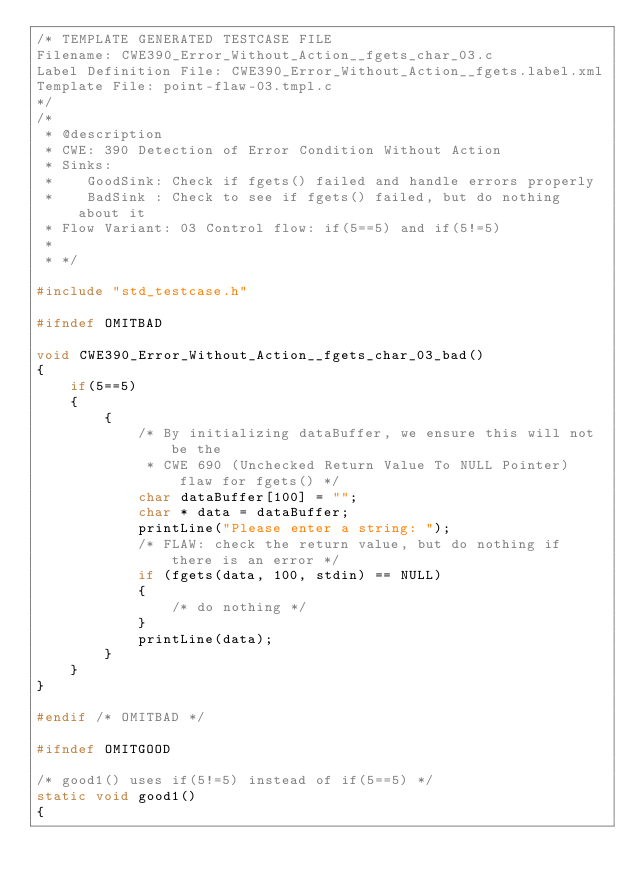Convert code to text. <code><loc_0><loc_0><loc_500><loc_500><_C_>/* TEMPLATE GENERATED TESTCASE FILE
Filename: CWE390_Error_Without_Action__fgets_char_03.c
Label Definition File: CWE390_Error_Without_Action__fgets.label.xml
Template File: point-flaw-03.tmpl.c
*/
/*
 * @description
 * CWE: 390 Detection of Error Condition Without Action
 * Sinks:
 *    GoodSink: Check if fgets() failed and handle errors properly
 *    BadSink : Check to see if fgets() failed, but do nothing about it
 * Flow Variant: 03 Control flow: if(5==5) and if(5!=5)
 *
 * */

#include "std_testcase.h"

#ifndef OMITBAD

void CWE390_Error_Without_Action__fgets_char_03_bad()
{
    if(5==5)
    {
        {
            /* By initializing dataBuffer, we ensure this will not be the
             * CWE 690 (Unchecked Return Value To NULL Pointer) flaw for fgets() */
            char dataBuffer[100] = "";
            char * data = dataBuffer;
            printLine("Please enter a string: ");
            /* FLAW: check the return value, but do nothing if there is an error */
            if (fgets(data, 100, stdin) == NULL)
            {
                /* do nothing */
            }
            printLine(data);
        }
    }
}

#endif /* OMITBAD */

#ifndef OMITGOOD

/* good1() uses if(5!=5) instead of if(5==5) */
static void good1()
{</code> 